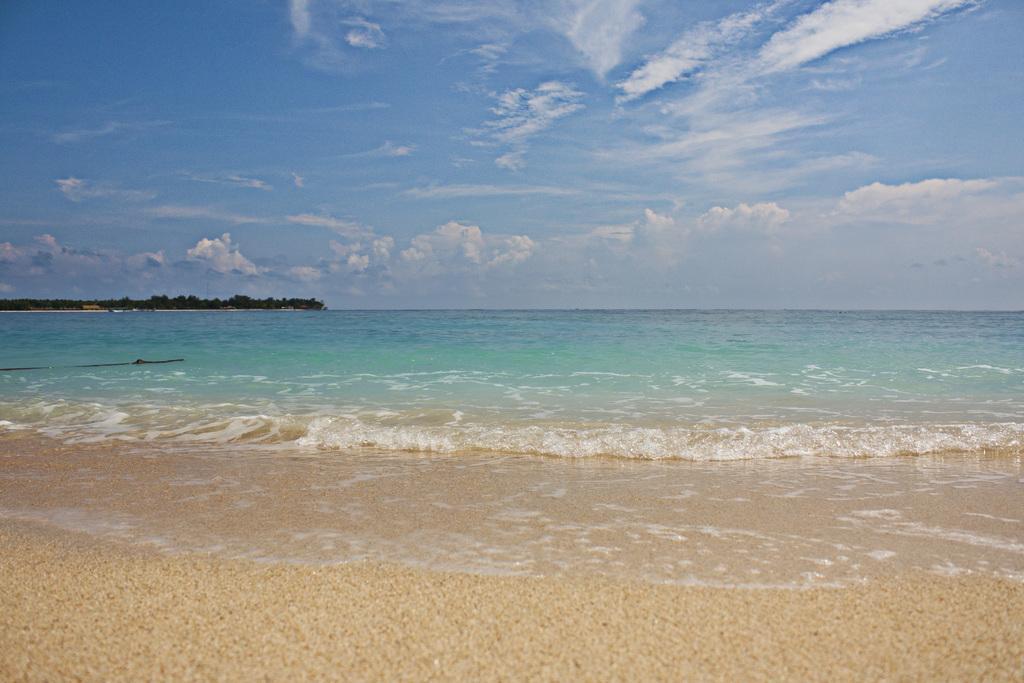How would you summarize this image in a sentence or two? In this picture we can see a water, sand i think this is a beach area and on the background we can see trees, sky with clouds. 